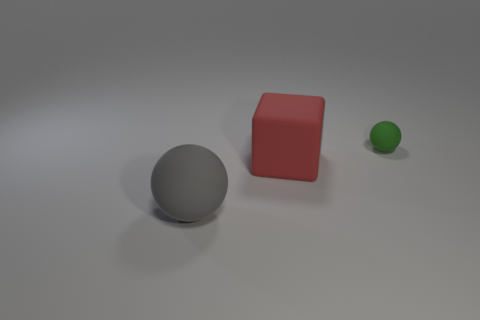Add 1 metal objects. How many objects exist? 4 Subtract all spheres. How many objects are left? 1 Subtract all matte spheres. Subtract all tiny blue rubber cubes. How many objects are left? 1 Add 1 tiny green spheres. How many tiny green spheres are left? 2 Add 3 gray matte things. How many gray matte things exist? 4 Subtract 0 gray cylinders. How many objects are left? 3 